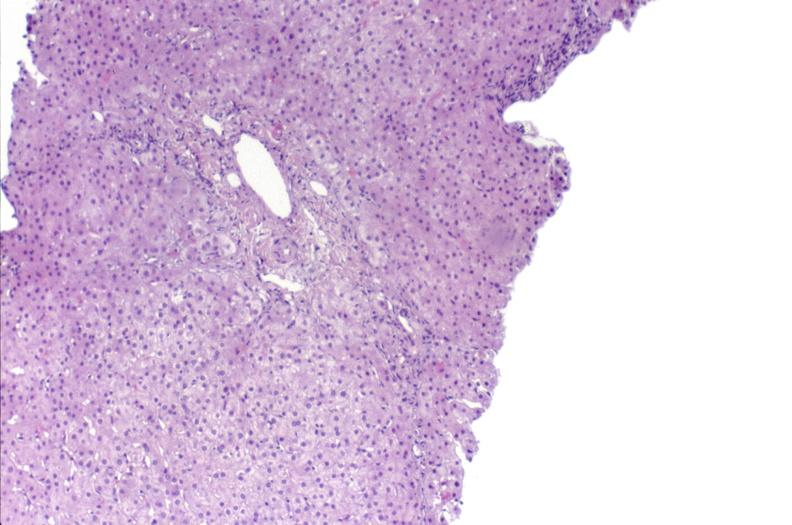s intrauterine contraceptive device present?
Answer the question using a single word or phrase. No 